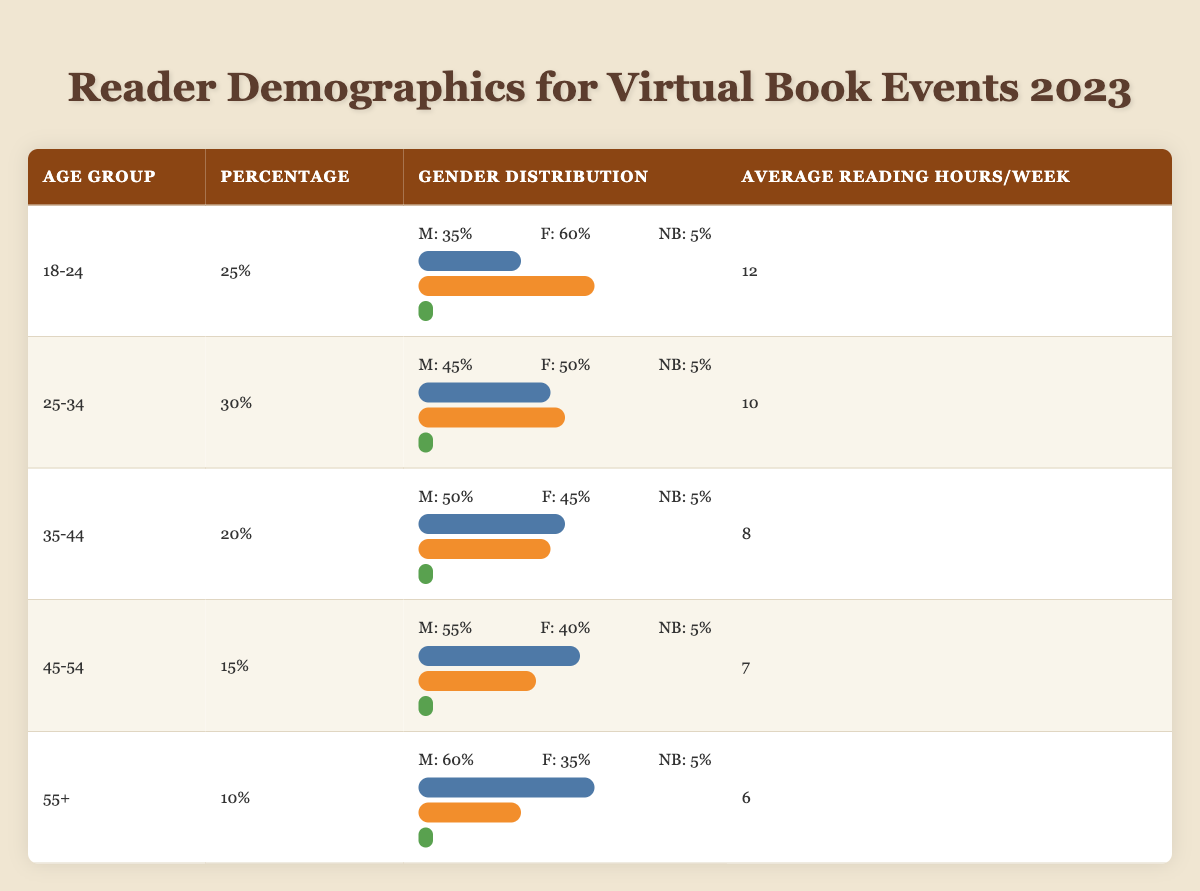What is the percentage of readers aged 18-24 participating in virtual book events in 2023? The table indicates that the percentage of readers aged 18-24 is directly listed in the "Percentage" column for that age group. It shows 25% for the age group 18-24.
Answer: 25% Which age group has the highest average reading hours per week? By looking at the "Average Reading Hours/Week" column, the highest value is found under the age group 18-24, with 12 hours per week, making it the group with the highest average reading hours.
Answer: 18-24 Is the gender distribution for the age group 35-44 more skewed towards males or females? In the age group 35-44, the gender distribution shows 50% male and 45% female. This indicates that there is a slight skew towards males since 50% is greater than 45%.
Answer: Yes What is the total percentage of readers from all age groups participating in virtual book events? Adding the percentages from all age groups: 25% + 30% + 20% + 15% + 10% gives a total of 100%. The percentages represent all age groups, confirming the total participation.
Answer: 100% On average, how many reading hours do participants aged 45-54 spend reading compared to those aged 55 and older? The average reading hours for the 45-54 age group is 7 hours, and for the 55+ age group, it is 6 hours. To compare, 7 hours for 45-54 is 1 hour more than 6 hours for 55+.
Answer: 1 hour more What is the percentage of non-binary readers in the 25-34 age group? The gender distribution for the 25-34 age group shows that 5% identify as non-binary. This value is listed directly under that age group's gender distribution section.
Answer: 5% Does the age group 55+ read more or less on average compared to the 35-44 age group? The average reading hours for the 55+ age group is 6 hours, while for the 35-44 age group, it is 8 hours. Since 6 is less than 8, it confirms that the 55+ age group reads less on average.
Answer: Less Calculate the average percentage of male readers across all age groups. The percentages for male readers are 35%, 45%, 50%, 55%, and 60% for the respective age groups. To find the average: (35 + 45 + 50 + 55 + 60) / 5 = 49%. This shows the central tendency of male readers across all groups.
Answer: 49% 